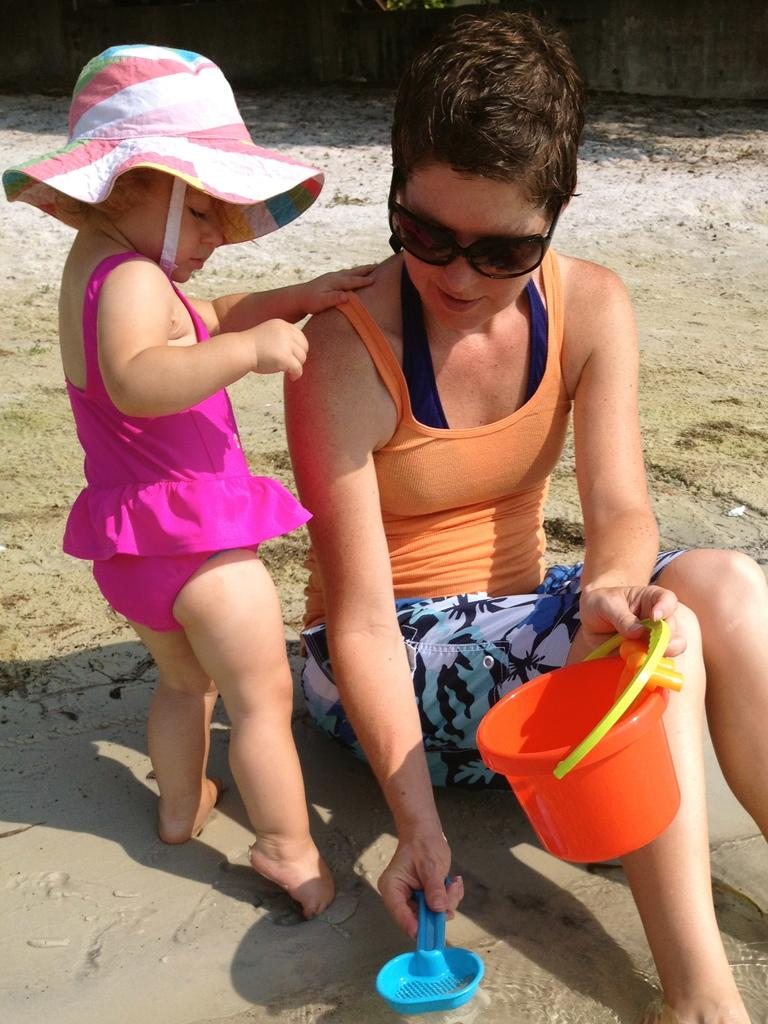How many people are present in the image? There are two people in the image. What else can be seen in the image besides the people? There are objects in the image. What is visible in the background of the image? There is a wall in the background of the image. What type of seed is being planted by the people in the image? There is no seed or planting activity depicted in the image. How does the pan help the people in the image? There is no pan present in the image. 